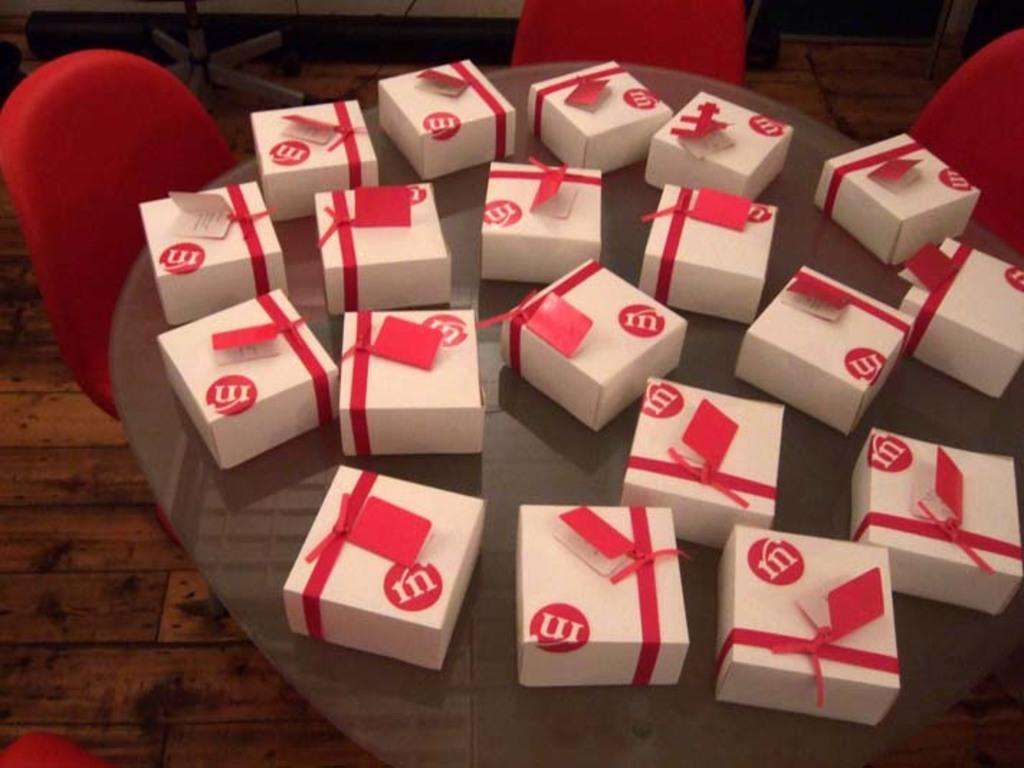<image>
Share a concise interpretation of the image provided. Several white boxed with red ribbon and a red letter "m" on them sit on a table. 